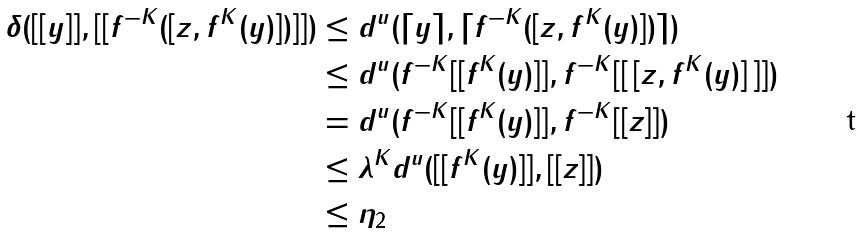<formula> <loc_0><loc_0><loc_500><loc_500>\delta ( [ [ y ] ] , [ [ f ^ { - K } ( [ z , f ^ { K } ( y ) ] ) ] ] ) & \leq d ^ { u } ( \lceil y \rceil , \lceil f ^ { - K } ( [ z , f ^ { K } ( y ) ] ) \rceil ) \\ & \leq d ^ { u } ( f ^ { - K } [ [ f ^ { K } ( y ) ] ] , f ^ { - K } [ [ \, [ z , f ^ { K } ( y ) ] \, ] ] ) \\ & = d ^ { u } ( f ^ { - K } [ [ f ^ { K } ( y ) ] ] , f ^ { - K } [ [ z ] ] ) \\ & \leq \lambda ^ { K } d ^ { u } ( [ [ f ^ { K } ( y ) ] ] , [ [ z ] ] ) \\ & \leq \eta _ { 2 }</formula> 